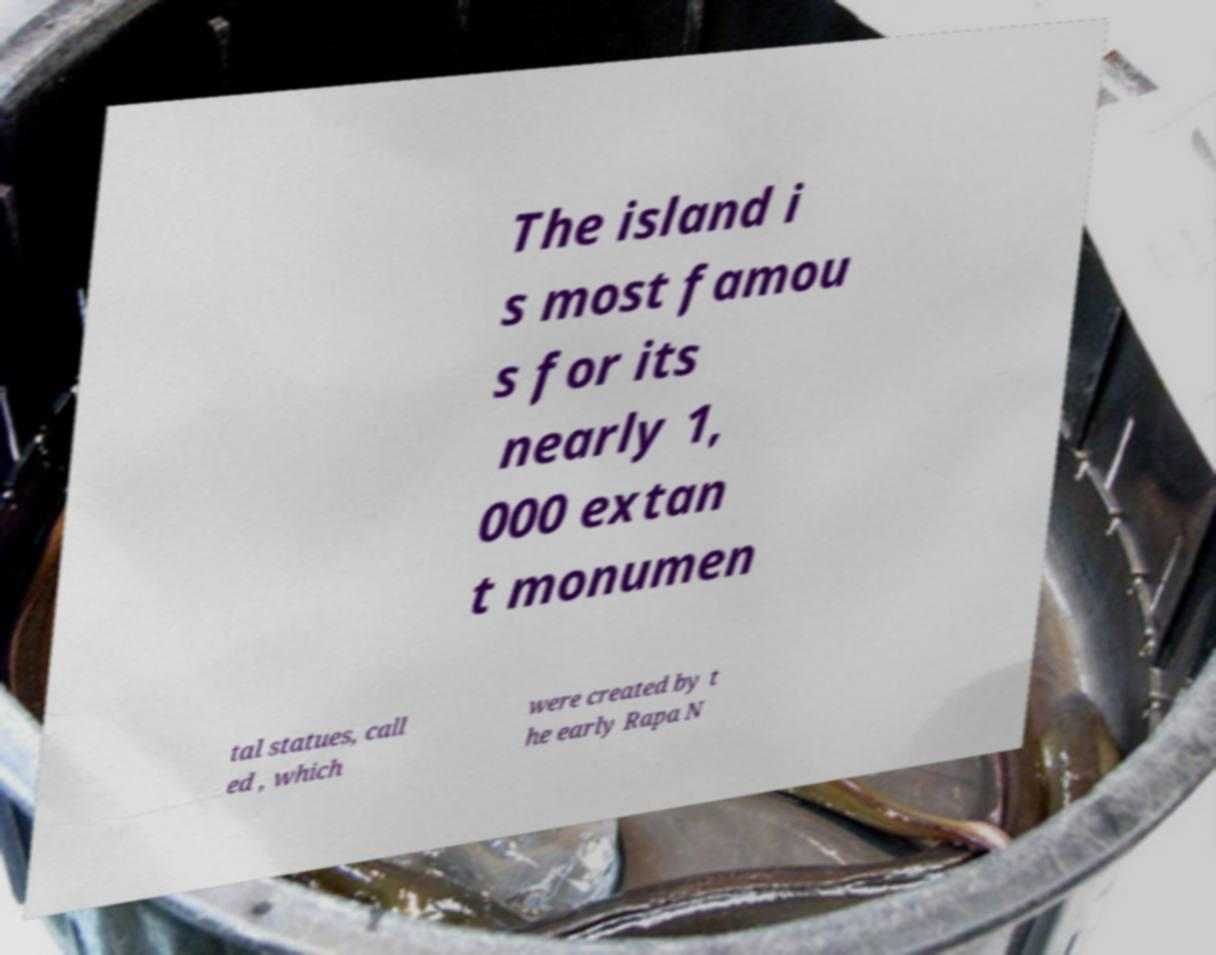Can you read and provide the text displayed in the image?This photo seems to have some interesting text. Can you extract and type it out for me? The island i s most famou s for its nearly 1, 000 extan t monumen tal statues, call ed , which were created by t he early Rapa N 